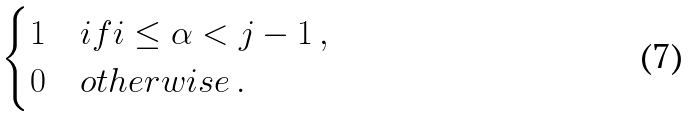Convert formula to latex. <formula><loc_0><loc_0><loc_500><loc_500>\begin{cases} 1 & i f i \leq \alpha < j - 1 \, , \\ 0 & o t h e r w i s e \, . \end{cases}</formula> 